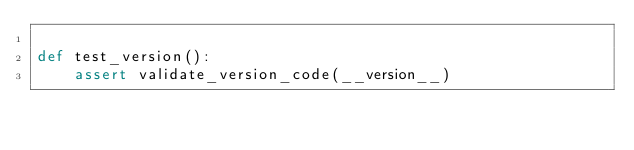<code> <loc_0><loc_0><loc_500><loc_500><_Python_>
def test_version():
    assert validate_version_code(__version__)</code> 